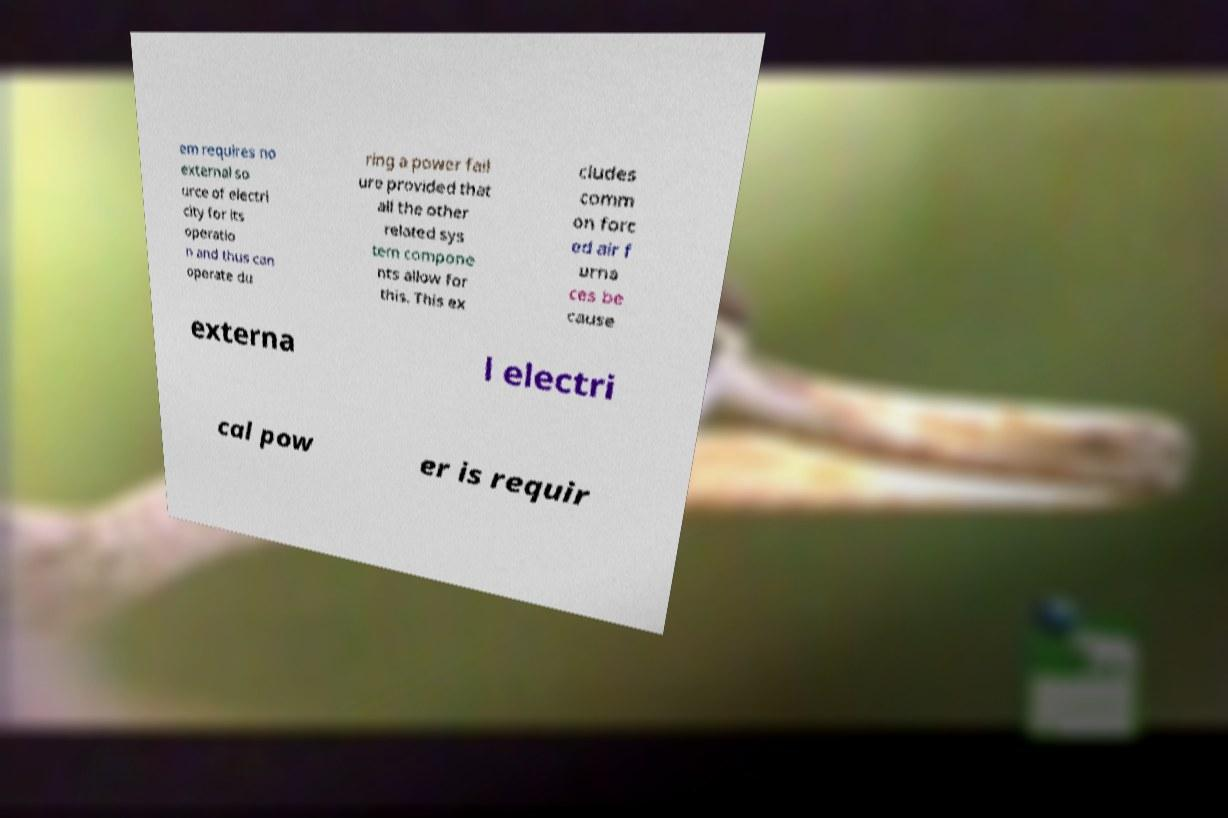Please read and relay the text visible in this image. What does it say? em requires no external so urce of electri city for its operatio n and thus can operate du ring a power fail ure provided that all the other related sys tem compone nts allow for this. This ex cludes comm on forc ed air f urna ces be cause externa l electri cal pow er is requir 